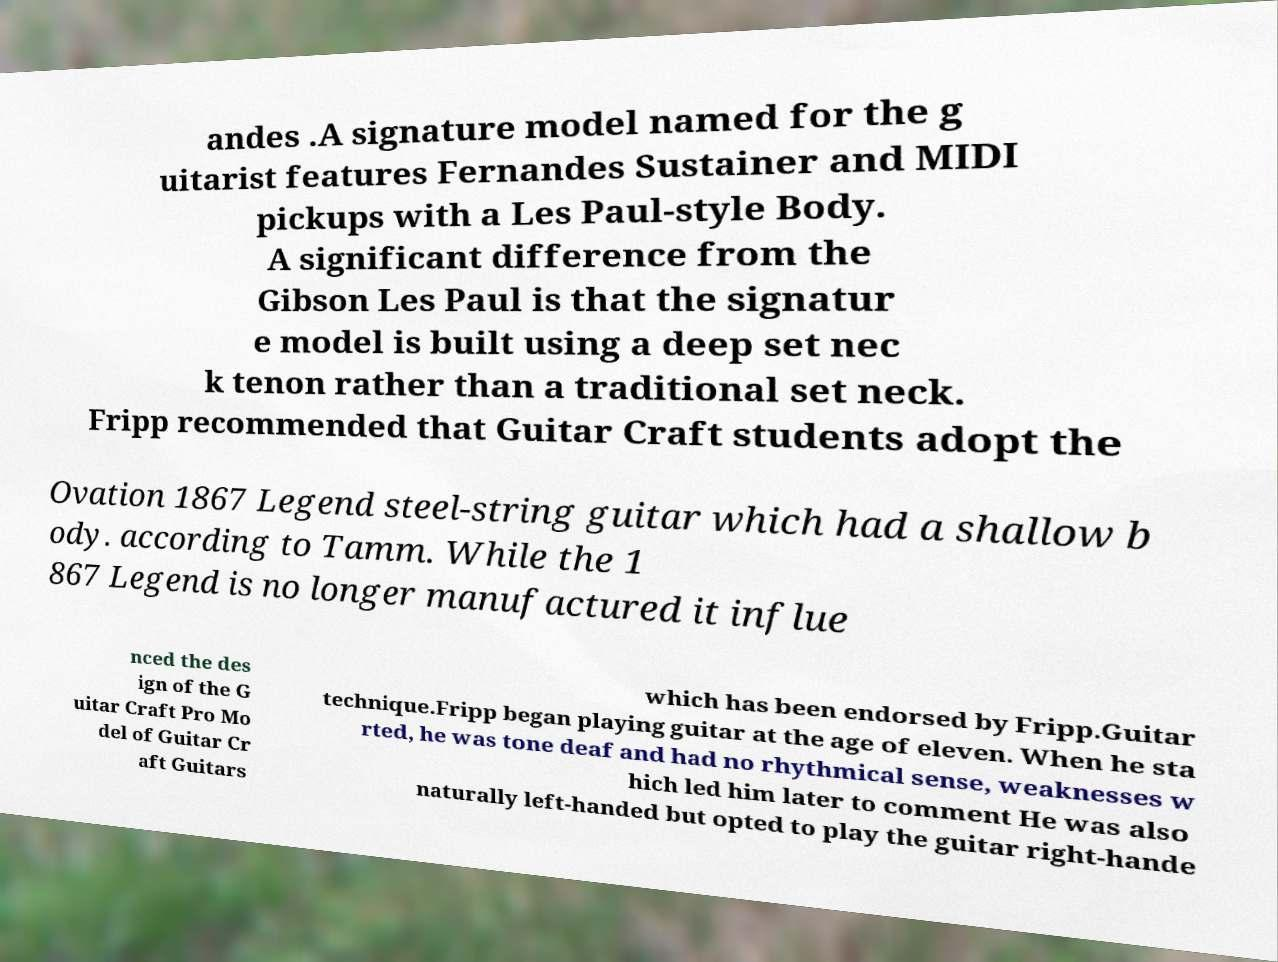I need the written content from this picture converted into text. Can you do that? andes .A signature model named for the g uitarist features Fernandes Sustainer and MIDI pickups with a Les Paul-style Body. A significant difference from the Gibson Les Paul is that the signatur e model is built using a deep set nec k tenon rather than a traditional set neck. Fripp recommended that Guitar Craft students adopt the Ovation 1867 Legend steel-string guitar which had a shallow b ody. according to Tamm. While the 1 867 Legend is no longer manufactured it influe nced the des ign of the G uitar Craft Pro Mo del of Guitar Cr aft Guitars which has been endorsed by Fripp.Guitar technique.Fripp began playing guitar at the age of eleven. When he sta rted, he was tone deaf and had no rhythmical sense, weaknesses w hich led him later to comment He was also naturally left-handed but opted to play the guitar right-hande 